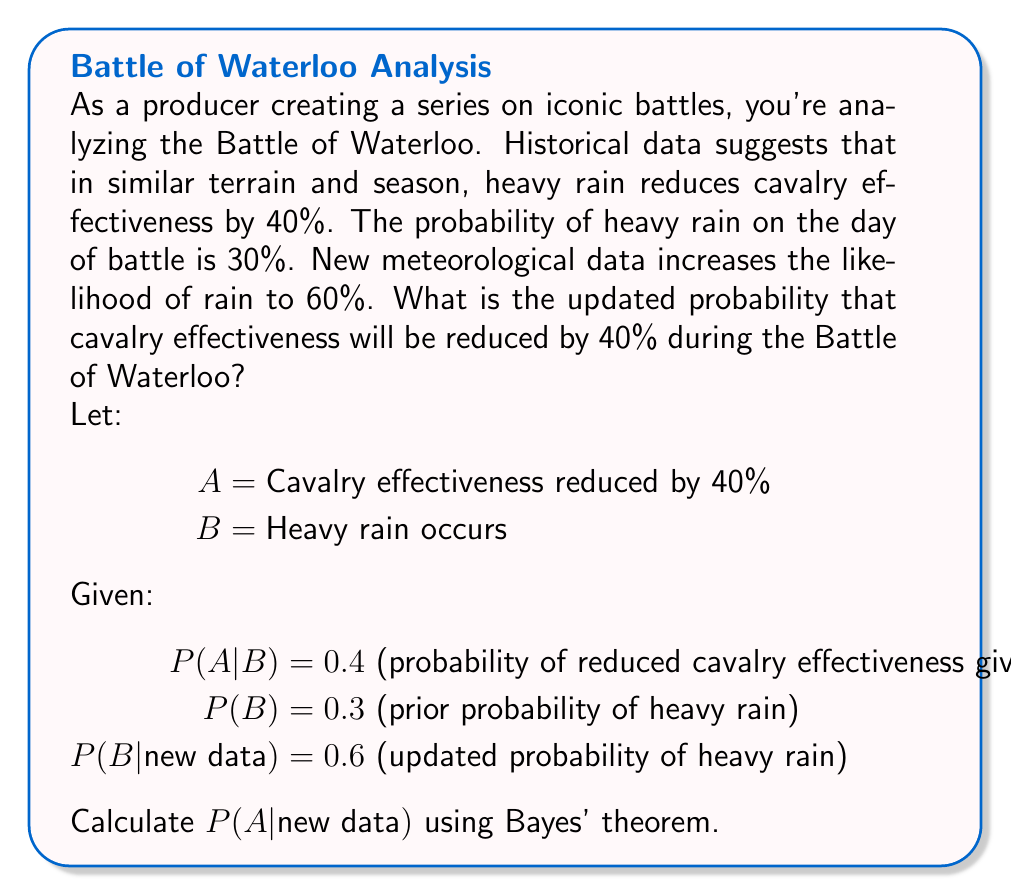Provide a solution to this math problem. To solve this problem, we'll use Bayes' theorem and the law of total probability. Let's break it down step-by-step:

1. First, we need to calculate P(A) using the law of total probability:
   $$P(A) = P(A|B)P(B) + P(A|\text{not B})P(\text{not B})$$
   
   We know P(A|B) = 0.4 and P(B) = 0.3, but we don't know P(A|not B). Let's assume it's 0 for simplicity.
   
   $$P(A) = 0.4 \times 0.3 + 0 \times 0.7 = 0.12$$

2. Now we can use Bayes' theorem to calculate P(B|A):
   $$P(B|A) = \frac{P(A|B)P(B)}{P(A)} = \frac{0.4 \times 0.3}{0.12} = 1$$

3. Next, we use Bayes' theorem again with the new data:
   $$P(A|\text{new data}) = P(A|B)P(B|\text{new data}) + P(A|\text{not B})P(\text{not B}|\text{new data})$$

   We know P(B|new data) = 0.6, so P(not B|new data) = 0.4

4. Substituting the values:
   $$P(A|\text{new data}) = 0.4 \times 0.6 + 0 \times 0.4 = 0.24$$

Therefore, given the new meteorological data, the updated probability that cavalry effectiveness will be reduced by 40% during the Battle of Waterloo is 0.24 or 24%.
Answer: 0.24 (24%) 